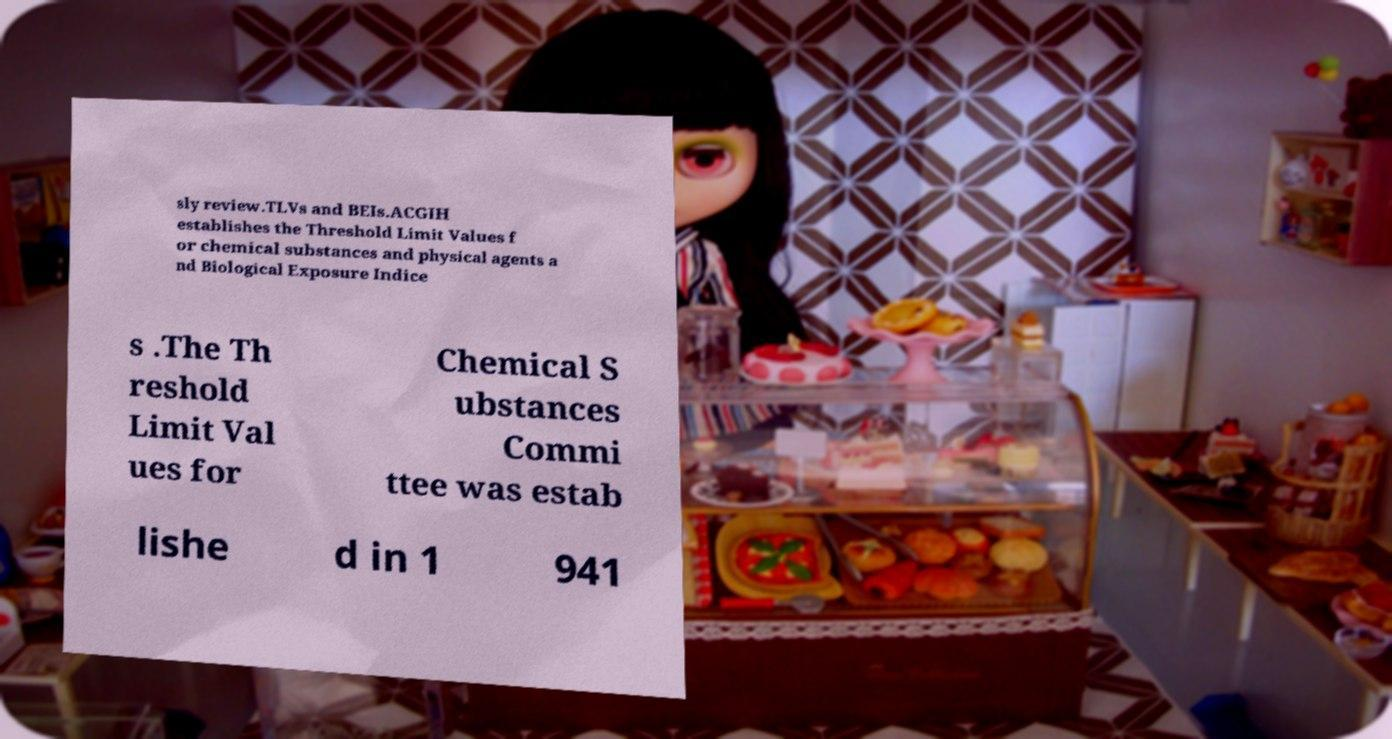I need the written content from this picture converted into text. Can you do that? sly review.TLVs and BEIs.ACGIH establishes the Threshold Limit Values f or chemical substances and physical agents a nd Biological Exposure Indice s .The Th reshold Limit Val ues for Chemical S ubstances Commi ttee was estab lishe d in 1 941 